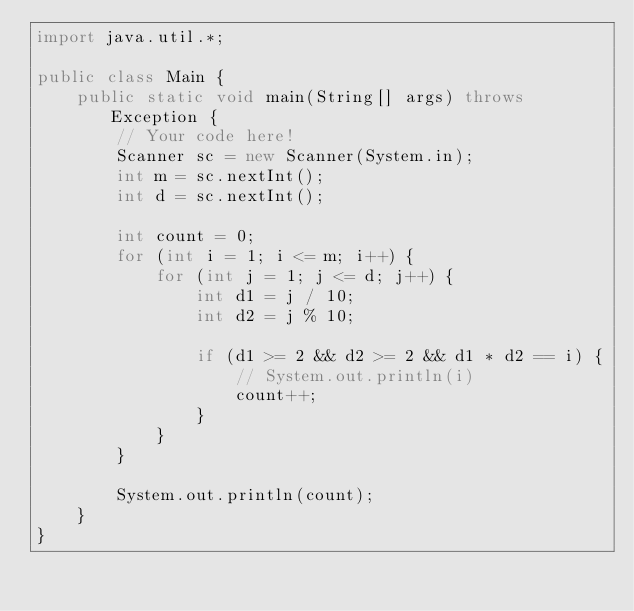Convert code to text. <code><loc_0><loc_0><loc_500><loc_500><_Java_>import java.util.*;

public class Main {
    public static void main(String[] args) throws Exception {
        // Your code here!
        Scanner sc = new Scanner(System.in);
        int m = sc.nextInt();
        int d = sc.nextInt();
        
        int count = 0;
        for (int i = 1; i <= m; i++) {
            for (int j = 1; j <= d; j++) {
                int d1 = j / 10;
                int d2 = j % 10;
                
                if (d1 >= 2 && d2 >= 2 && d1 * d2 == i) {
                    // System.out.println(i)
                    count++;
                }
            }
        }
        
        System.out.println(count);
    }
}</code> 